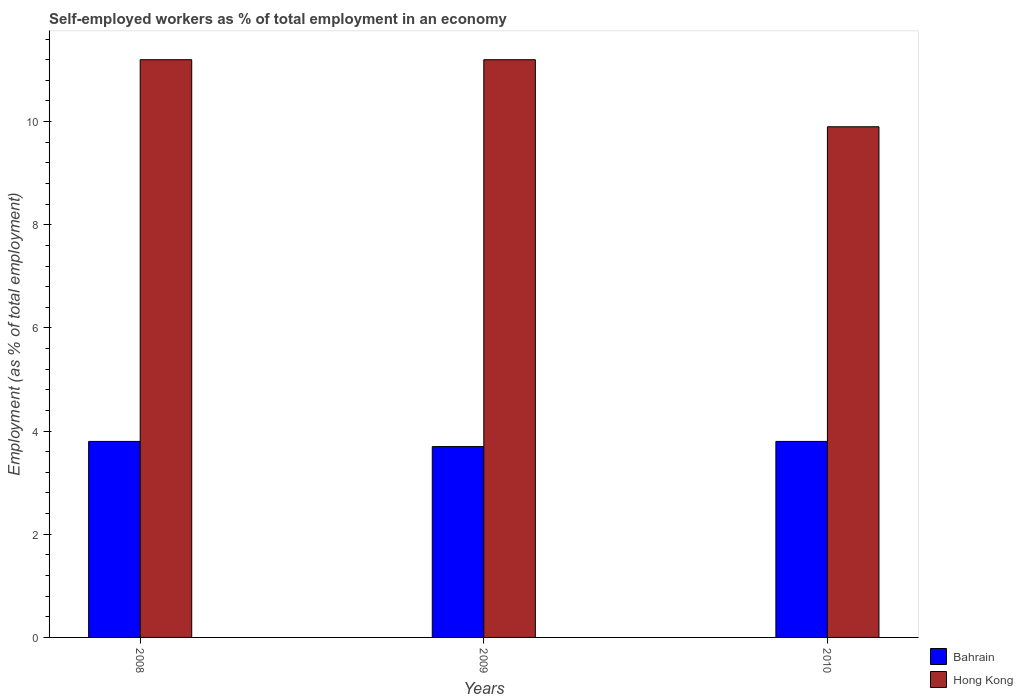Are the number of bars per tick equal to the number of legend labels?
Your answer should be very brief. Yes. What is the label of the 3rd group of bars from the left?
Offer a terse response. 2010. In how many cases, is the number of bars for a given year not equal to the number of legend labels?
Ensure brevity in your answer.  0. What is the percentage of self-employed workers in Hong Kong in 2009?
Give a very brief answer. 11.2. Across all years, what is the maximum percentage of self-employed workers in Hong Kong?
Your response must be concise. 11.2. Across all years, what is the minimum percentage of self-employed workers in Bahrain?
Ensure brevity in your answer.  3.7. In which year was the percentage of self-employed workers in Bahrain maximum?
Keep it short and to the point. 2008. What is the total percentage of self-employed workers in Bahrain in the graph?
Ensure brevity in your answer.  11.3. What is the difference between the percentage of self-employed workers in Hong Kong in 2009 and that in 2010?
Your answer should be very brief. 1.3. What is the difference between the percentage of self-employed workers in Bahrain in 2008 and the percentage of self-employed workers in Hong Kong in 2010?
Provide a short and direct response. -6.1. What is the average percentage of self-employed workers in Hong Kong per year?
Offer a terse response. 10.77. In the year 2009, what is the difference between the percentage of self-employed workers in Bahrain and percentage of self-employed workers in Hong Kong?
Offer a very short reply. -7.5. What is the ratio of the percentage of self-employed workers in Bahrain in 2008 to that in 2009?
Provide a succinct answer. 1.03. Is the difference between the percentage of self-employed workers in Bahrain in 2009 and 2010 greater than the difference between the percentage of self-employed workers in Hong Kong in 2009 and 2010?
Make the answer very short. No. What is the difference between the highest and the lowest percentage of self-employed workers in Hong Kong?
Your response must be concise. 1.3. In how many years, is the percentage of self-employed workers in Hong Kong greater than the average percentage of self-employed workers in Hong Kong taken over all years?
Offer a terse response. 2. Is the sum of the percentage of self-employed workers in Hong Kong in 2008 and 2010 greater than the maximum percentage of self-employed workers in Bahrain across all years?
Provide a short and direct response. Yes. What does the 1st bar from the left in 2008 represents?
Your answer should be very brief. Bahrain. What does the 1st bar from the right in 2008 represents?
Your response must be concise. Hong Kong. What is the difference between two consecutive major ticks on the Y-axis?
Offer a very short reply. 2. What is the title of the graph?
Provide a short and direct response. Self-employed workers as % of total employment in an economy. What is the label or title of the Y-axis?
Your response must be concise. Employment (as % of total employment). What is the Employment (as % of total employment) of Bahrain in 2008?
Keep it short and to the point. 3.8. What is the Employment (as % of total employment) in Hong Kong in 2008?
Ensure brevity in your answer.  11.2. What is the Employment (as % of total employment) of Bahrain in 2009?
Offer a terse response. 3.7. What is the Employment (as % of total employment) in Hong Kong in 2009?
Your answer should be very brief. 11.2. What is the Employment (as % of total employment) in Bahrain in 2010?
Keep it short and to the point. 3.8. What is the Employment (as % of total employment) in Hong Kong in 2010?
Keep it short and to the point. 9.9. Across all years, what is the maximum Employment (as % of total employment) in Bahrain?
Your answer should be very brief. 3.8. Across all years, what is the maximum Employment (as % of total employment) in Hong Kong?
Your response must be concise. 11.2. Across all years, what is the minimum Employment (as % of total employment) in Bahrain?
Your response must be concise. 3.7. Across all years, what is the minimum Employment (as % of total employment) of Hong Kong?
Ensure brevity in your answer.  9.9. What is the total Employment (as % of total employment) of Hong Kong in the graph?
Your answer should be very brief. 32.3. What is the difference between the Employment (as % of total employment) of Bahrain in 2008 and that in 2010?
Give a very brief answer. 0. What is the difference between the Employment (as % of total employment) in Hong Kong in 2008 and that in 2010?
Ensure brevity in your answer.  1.3. What is the difference between the Employment (as % of total employment) in Bahrain in 2009 and that in 2010?
Your answer should be very brief. -0.1. What is the difference between the Employment (as % of total employment) in Hong Kong in 2009 and that in 2010?
Your answer should be compact. 1.3. What is the difference between the Employment (as % of total employment) of Bahrain in 2008 and the Employment (as % of total employment) of Hong Kong in 2009?
Ensure brevity in your answer.  -7.4. What is the difference between the Employment (as % of total employment) in Bahrain in 2009 and the Employment (as % of total employment) in Hong Kong in 2010?
Give a very brief answer. -6.2. What is the average Employment (as % of total employment) of Bahrain per year?
Offer a very short reply. 3.77. What is the average Employment (as % of total employment) of Hong Kong per year?
Provide a succinct answer. 10.77. In the year 2008, what is the difference between the Employment (as % of total employment) of Bahrain and Employment (as % of total employment) of Hong Kong?
Offer a very short reply. -7.4. In the year 2010, what is the difference between the Employment (as % of total employment) in Bahrain and Employment (as % of total employment) in Hong Kong?
Your answer should be compact. -6.1. What is the ratio of the Employment (as % of total employment) in Hong Kong in 2008 to that in 2010?
Provide a succinct answer. 1.13. What is the ratio of the Employment (as % of total employment) of Bahrain in 2009 to that in 2010?
Keep it short and to the point. 0.97. What is the ratio of the Employment (as % of total employment) in Hong Kong in 2009 to that in 2010?
Your response must be concise. 1.13. What is the difference between the highest and the second highest Employment (as % of total employment) of Bahrain?
Offer a terse response. 0. What is the difference between the highest and the second highest Employment (as % of total employment) of Hong Kong?
Ensure brevity in your answer.  0. What is the difference between the highest and the lowest Employment (as % of total employment) of Hong Kong?
Offer a very short reply. 1.3. 